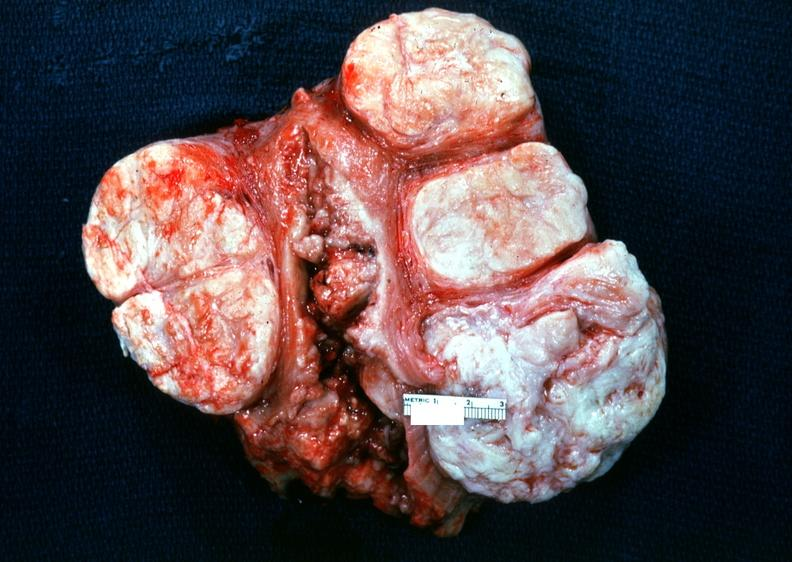where does this part belong to?
Answer the question using a single word or phrase. Female reproductive system 